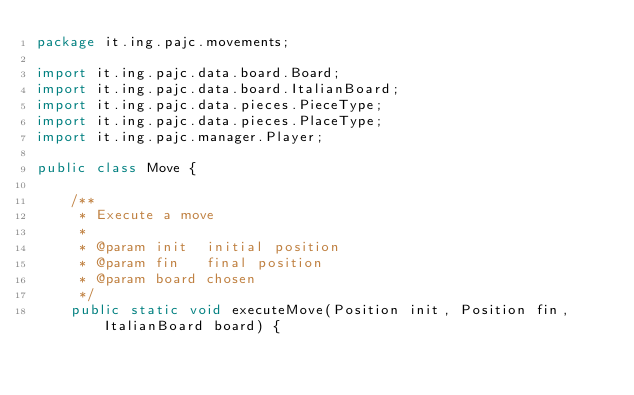<code> <loc_0><loc_0><loc_500><loc_500><_Java_>package it.ing.pajc.movements;

import it.ing.pajc.data.board.Board;
import it.ing.pajc.data.board.ItalianBoard;
import it.ing.pajc.data.pieces.PieceType;
import it.ing.pajc.data.pieces.PlaceType;
import it.ing.pajc.manager.Player;

public class Move {

    /**
     * Execute a move
     *
     * @param init  initial position
     * @param fin   final position
     * @param board chosen
     */
    public static void executeMove(Position init, Position fin, ItalianBoard board) {</code> 